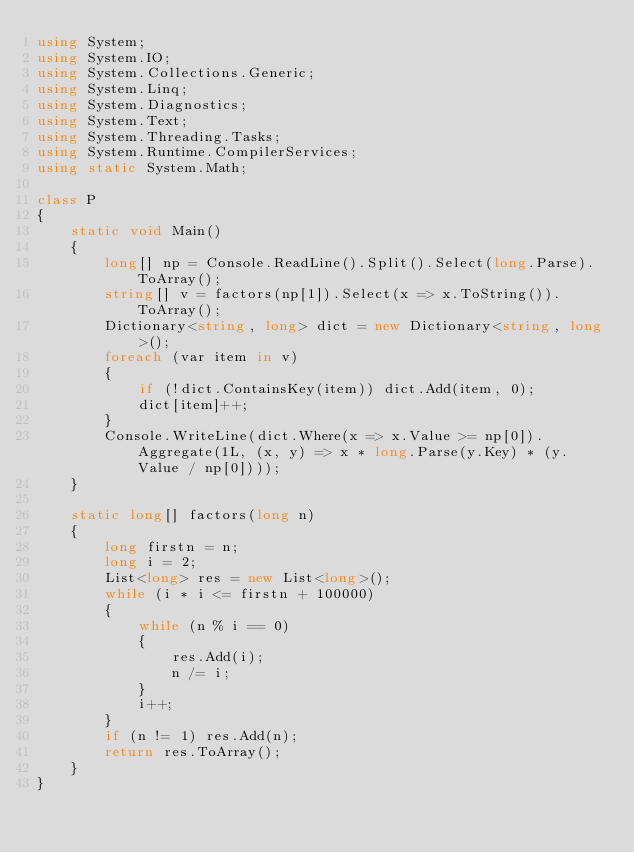<code> <loc_0><loc_0><loc_500><loc_500><_C#_>using System;
using System.IO;
using System.Collections.Generic;
using System.Linq;
using System.Diagnostics;
using System.Text;
using System.Threading.Tasks;
using System.Runtime.CompilerServices;
using static System.Math;

class P
{
    static void Main()
    {
        long[] np = Console.ReadLine().Split().Select(long.Parse).ToArray();
        string[] v = factors(np[1]).Select(x => x.ToString()).ToArray();
        Dictionary<string, long> dict = new Dictionary<string, long>();
        foreach (var item in v)
        {
            if (!dict.ContainsKey(item)) dict.Add(item, 0);
            dict[item]++;
        }
        Console.WriteLine(dict.Where(x => x.Value >= np[0]).Aggregate(1L, (x, y) => x * long.Parse(y.Key) * (y.Value / np[0])));    
    }

    static long[] factors(long n)
    {
        long firstn = n;
        long i = 2;
        List<long> res = new List<long>();
        while (i * i <= firstn + 100000)
        {
            while (n % i == 0)
            {
                res.Add(i);
                n /= i;
            }
            i++;
        }
        if (n != 1) res.Add(n);
        return res.ToArray();
    }
}
</code> 